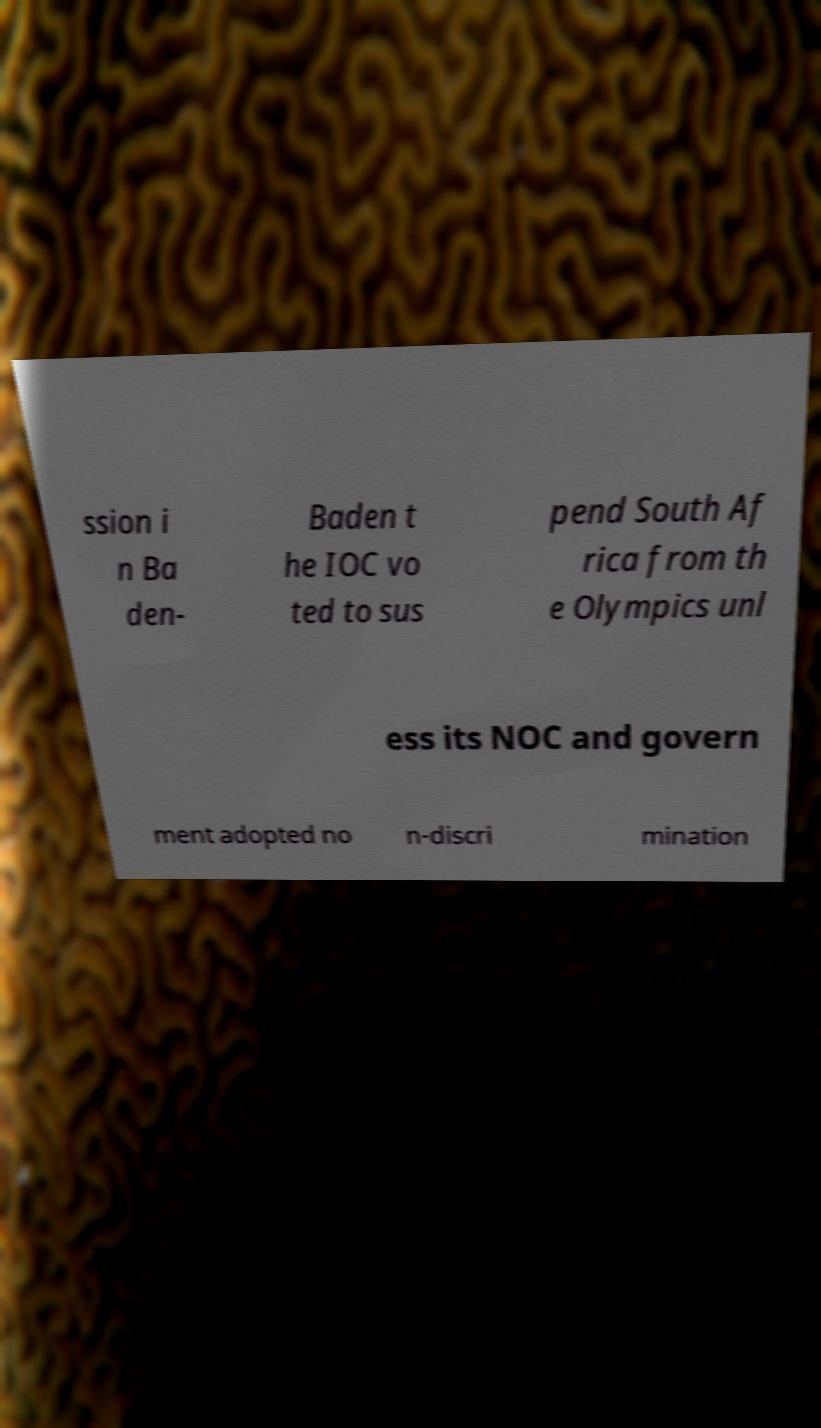Please identify and transcribe the text found in this image. ssion i n Ba den- Baden t he IOC vo ted to sus pend South Af rica from th e Olympics unl ess its NOC and govern ment adopted no n-discri mination 